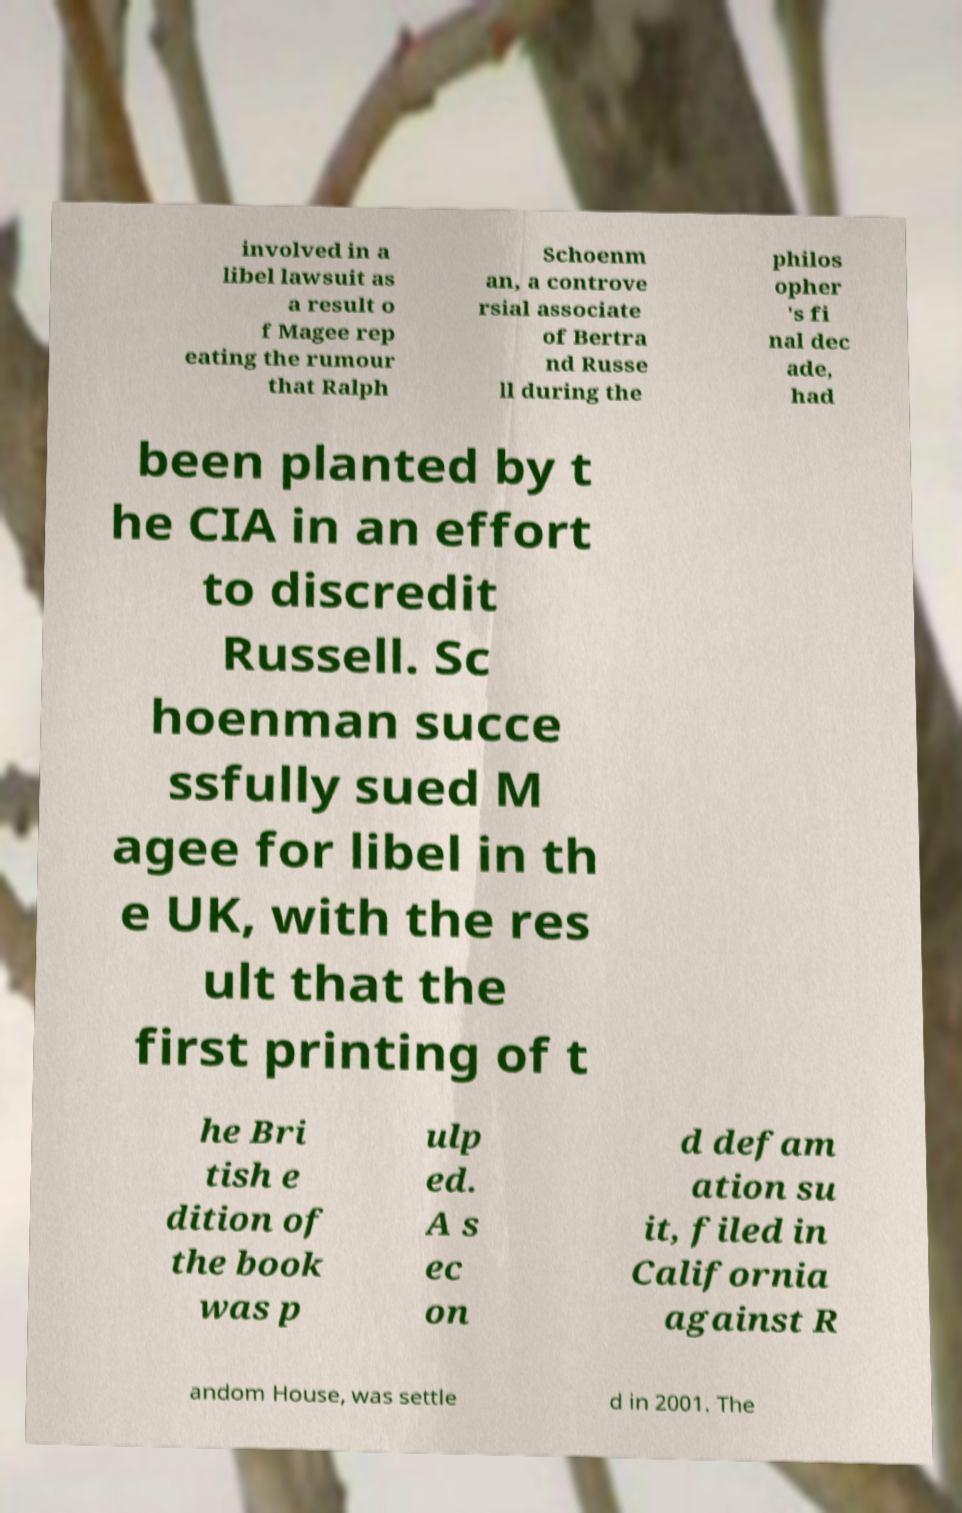Please read and relay the text visible in this image. What does it say? involved in a libel lawsuit as a result o f Magee rep eating the rumour that Ralph Schoenm an, a controve rsial associate of Bertra nd Russe ll during the philos opher 's fi nal dec ade, had been planted by t he CIA in an effort to discredit Russell. Sc hoenman succe ssfully sued M agee for libel in th e UK, with the res ult that the first printing of t he Bri tish e dition of the book was p ulp ed. A s ec on d defam ation su it, filed in California against R andom House, was settle d in 2001. The 